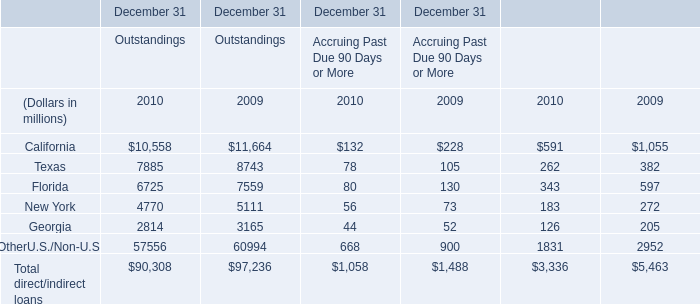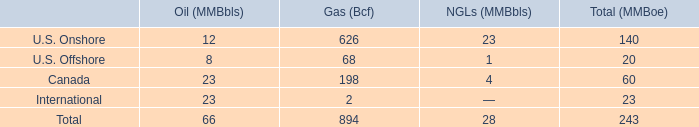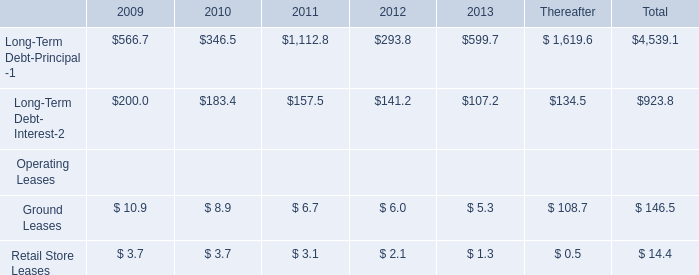What's the current growth rate of total direct/indirect loans of Outstandings? 
Computations: ((90308 - 97236) / 97236)
Answer: -0.07125. 